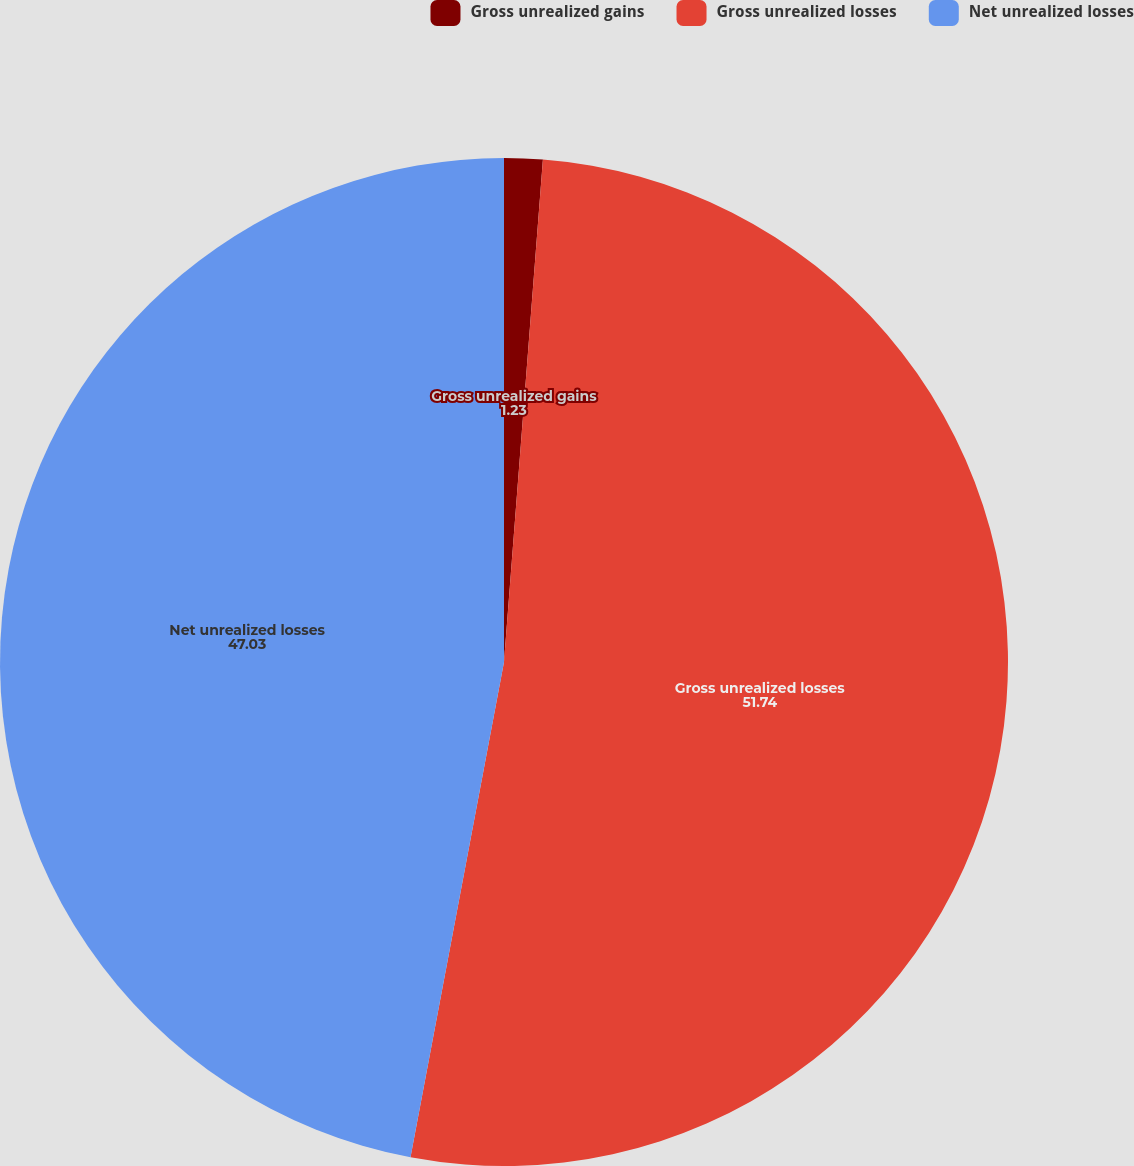Convert chart to OTSL. <chart><loc_0><loc_0><loc_500><loc_500><pie_chart><fcel>Gross unrealized gains<fcel>Gross unrealized losses<fcel>Net unrealized losses<nl><fcel>1.23%<fcel>51.74%<fcel>47.03%<nl></chart> 